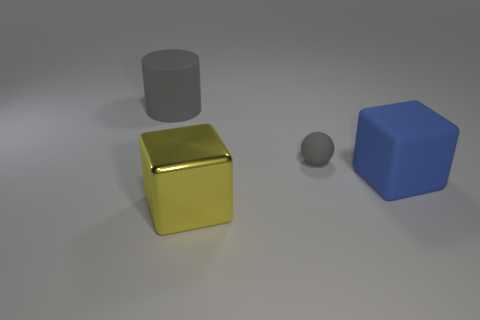Add 1 gray matte balls. How many objects exist? 5 Subtract all green blocks. Subtract all green spheres. How many blocks are left? 2 Subtract all balls. How many objects are left? 3 Subtract 0 brown cylinders. How many objects are left? 4 Subtract all matte cubes. Subtract all large rubber things. How many objects are left? 1 Add 4 big blue rubber objects. How many big blue rubber objects are left? 5 Add 3 large gray objects. How many large gray objects exist? 4 